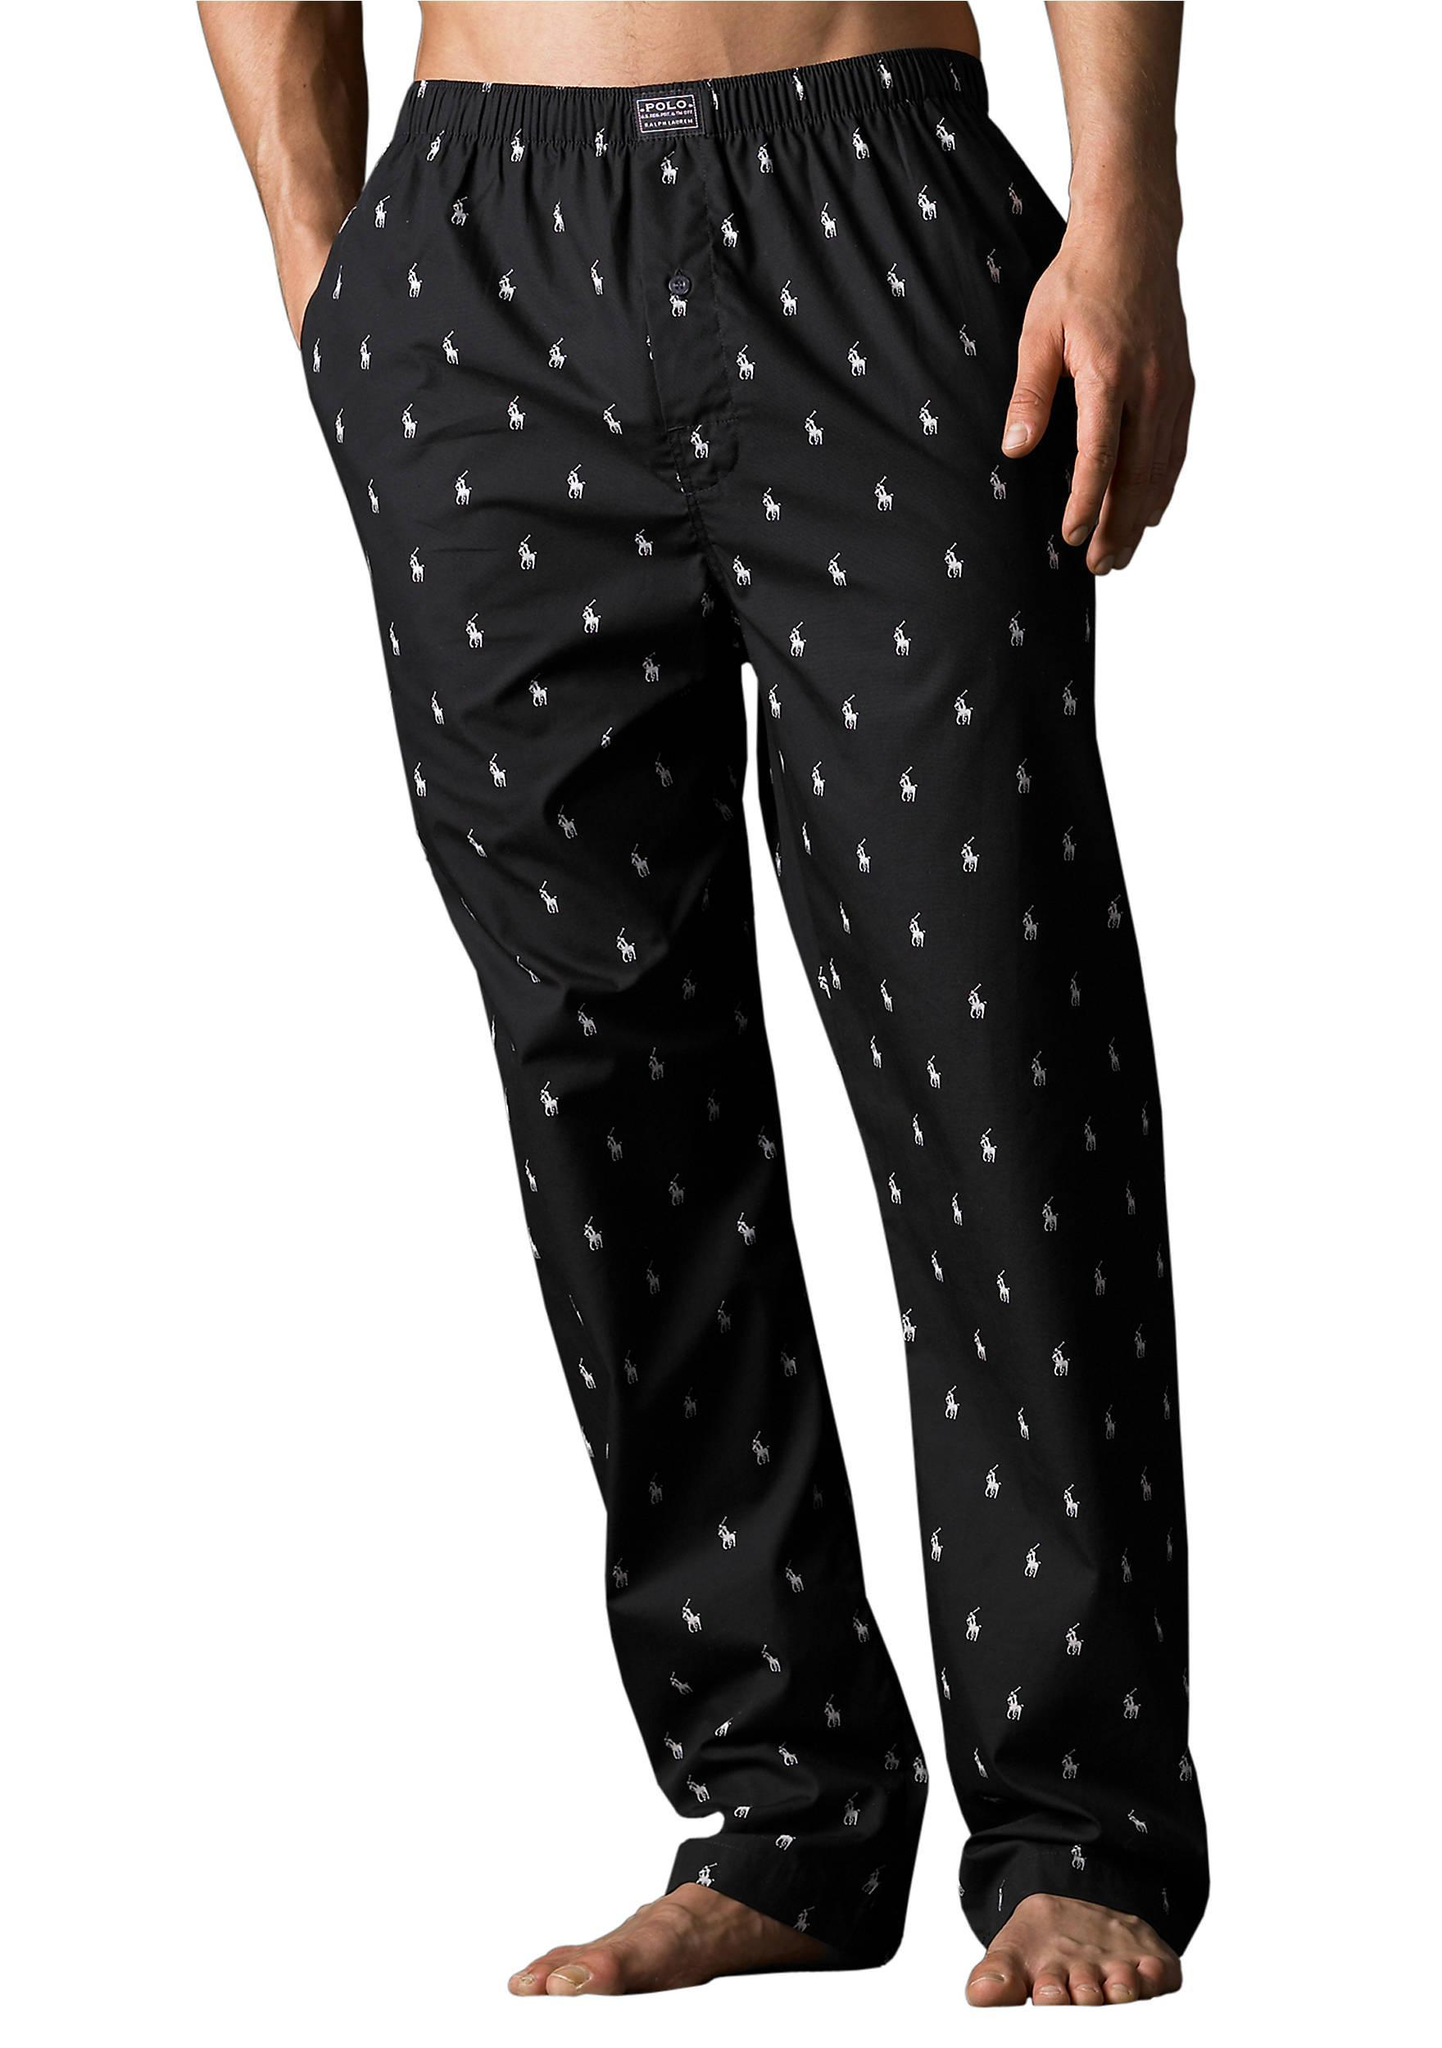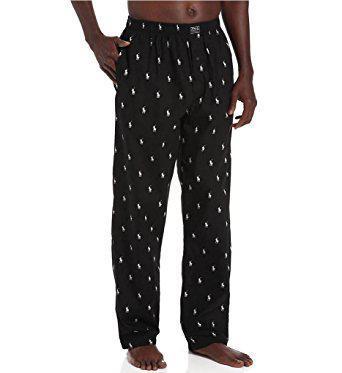The first image is the image on the left, the second image is the image on the right. Assess this claim about the two images: "The pants do not have a repeating pattern on them.". Correct or not? Answer yes or no. No. 